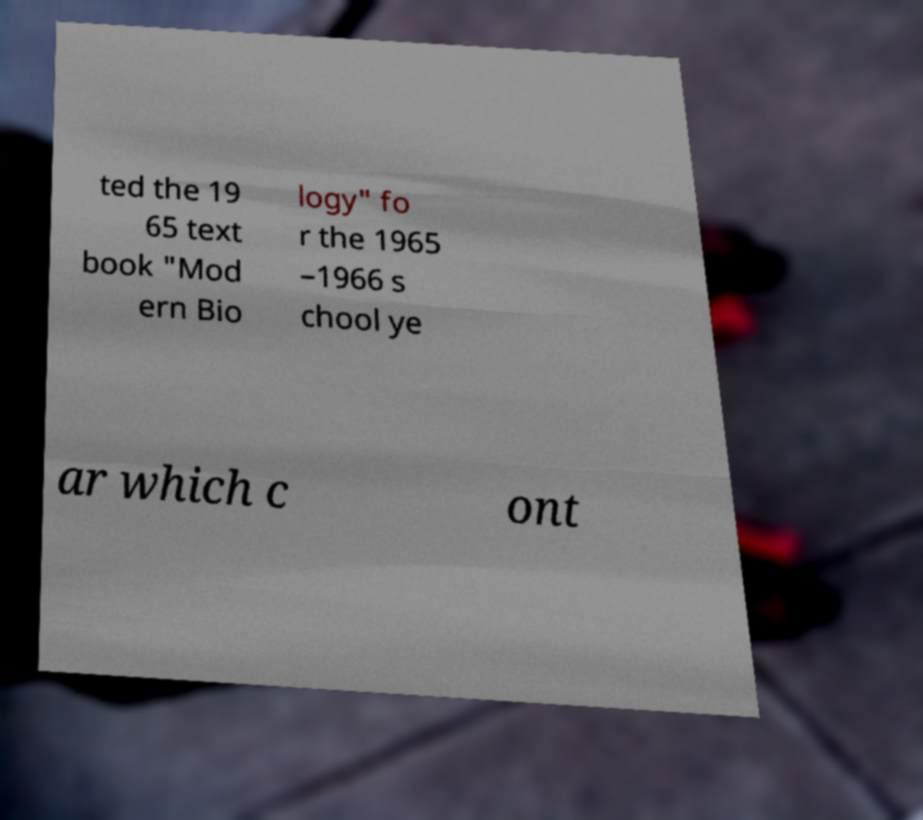Can you read and provide the text displayed in the image?This photo seems to have some interesting text. Can you extract and type it out for me? ted the 19 65 text book "Mod ern Bio logy" fo r the 1965 –1966 s chool ye ar which c ont 